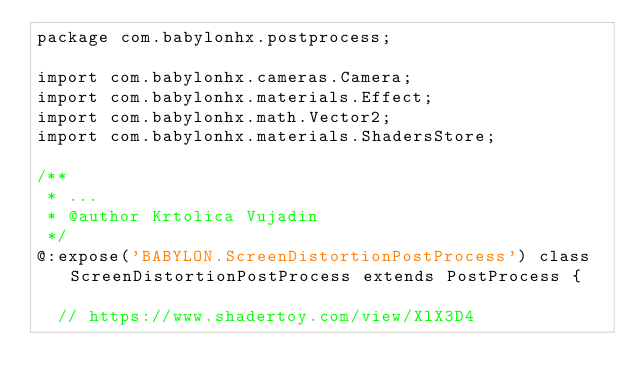Convert code to text. <code><loc_0><loc_0><loc_500><loc_500><_Haxe_>package com.babylonhx.postprocess;

import com.babylonhx.cameras.Camera;
import com.babylonhx.materials.Effect;
import com.babylonhx.math.Vector2;
import com.babylonhx.materials.ShadersStore;

/**
 * ...
 * @author Krtolica Vujadin
 */
@:expose('BABYLON.ScreenDistortionPostProcess') class ScreenDistortionPostProcess extends PostProcess {

	// https://www.shadertoy.com/view/XlX3D4</code> 